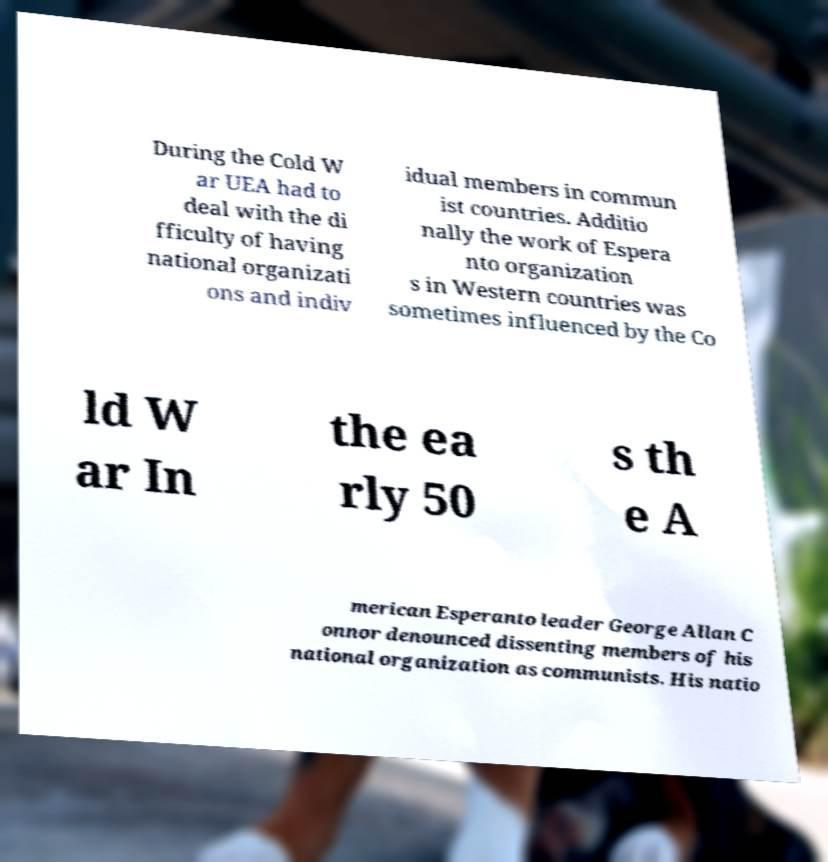For documentation purposes, I need the text within this image transcribed. Could you provide that? During the Cold W ar UEA had to deal with the di fficulty of having national organizati ons and indiv idual members in commun ist countries. Additio nally the work of Espera nto organization s in Western countries was sometimes influenced by the Co ld W ar In the ea rly 50 s th e A merican Esperanto leader George Allan C onnor denounced dissenting members of his national organization as communists. His natio 